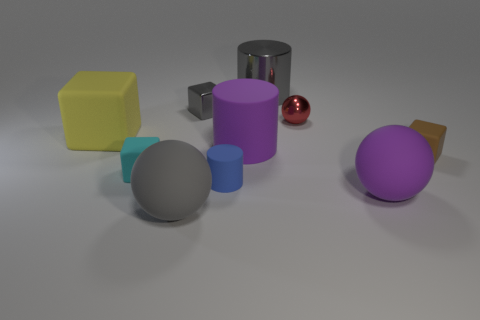Are there any other things that have the same color as the large matte cylinder?
Your response must be concise. Yes. Is the shiny block the same color as the metal cylinder?
Give a very brief answer. Yes. What number of gray things are either large cylinders or large spheres?
Keep it short and to the point. 2. What is the color of the tiny cylinder that is the same material as the big yellow cube?
Your answer should be very brief. Blue. Does the purple object that is behind the tiny blue thing have the same material as the small cube to the right of the small gray metallic object?
Ensure brevity in your answer.  Yes. The rubber sphere that is the same color as the big metallic object is what size?
Your answer should be very brief. Large. There is a gray block left of the red thing; what is it made of?
Ensure brevity in your answer.  Metal. Does the gray shiny object that is behind the small gray object have the same shape as the small red shiny object on the right side of the yellow thing?
Offer a terse response. No. What material is the cube that is the same color as the large metallic object?
Provide a short and direct response. Metal. Are there any red metal cylinders?
Your answer should be compact. No. 